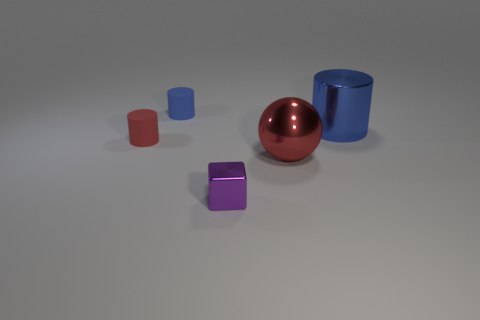Add 2 spheres. How many objects exist? 7 Subtract all cylinders. How many objects are left? 2 Add 3 small blue rubber cylinders. How many small blue rubber cylinders are left? 4 Add 4 large cylinders. How many large cylinders exist? 5 Subtract 0 gray blocks. How many objects are left? 5 Subtract all large metal cylinders. Subtract all green shiny cubes. How many objects are left? 4 